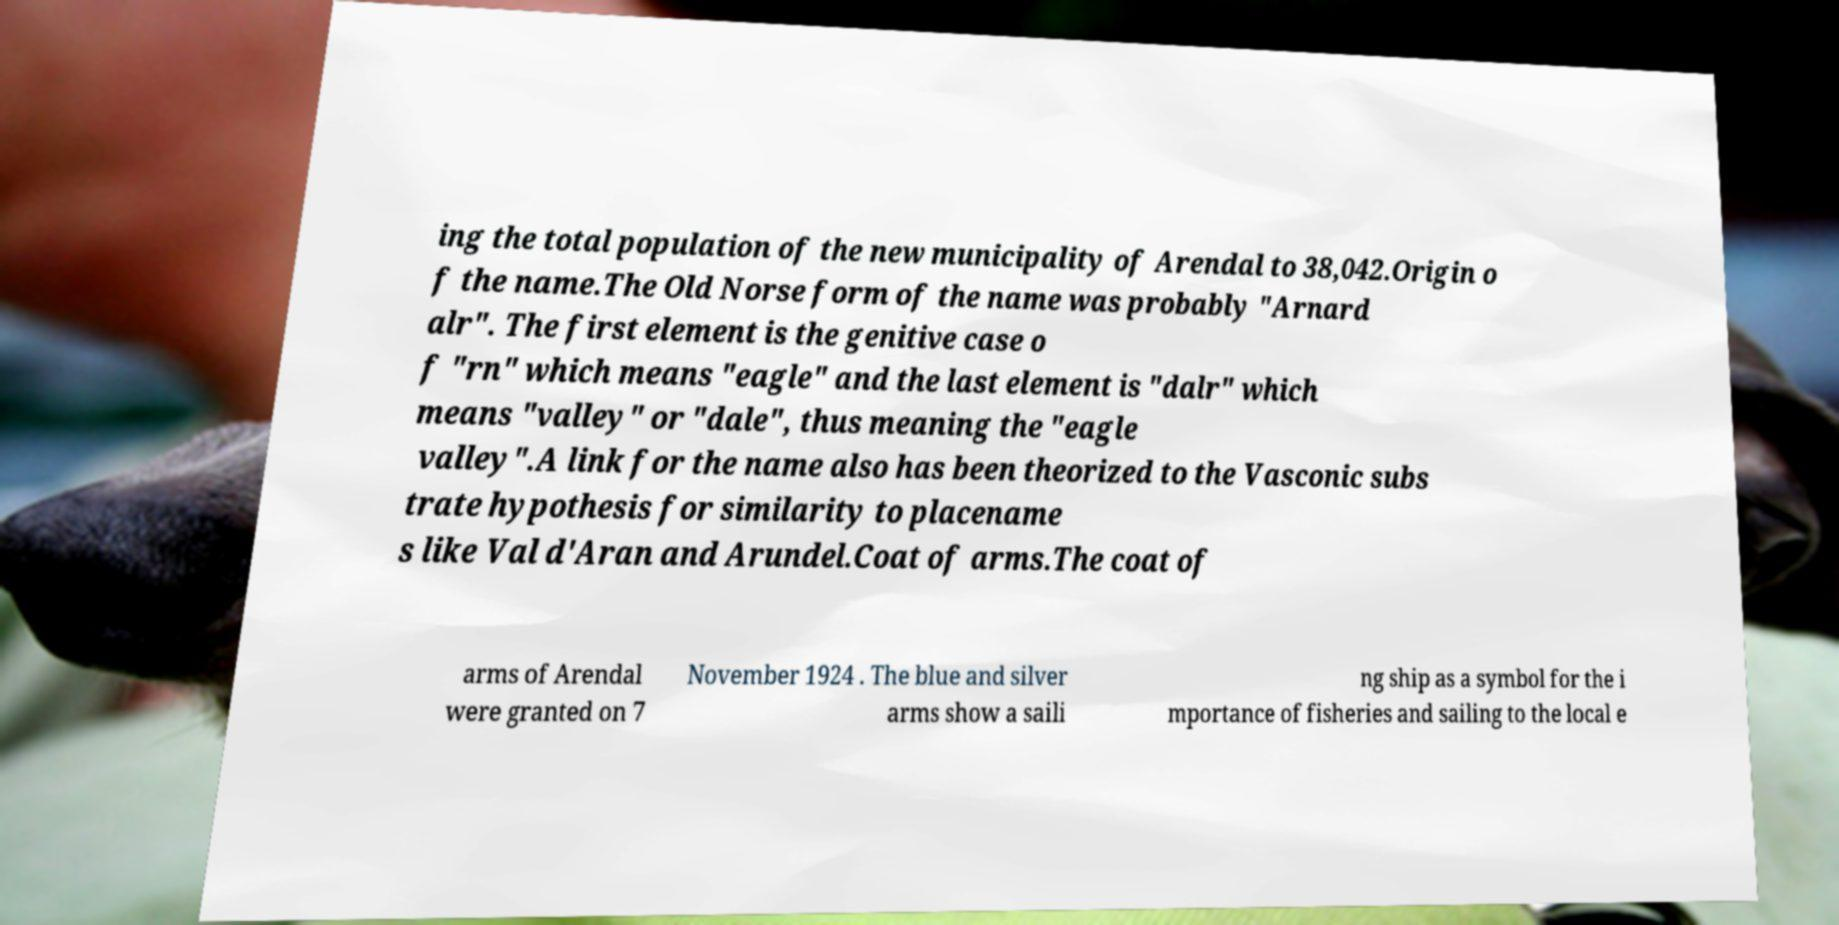Please read and relay the text visible in this image. What does it say? ing the total population of the new municipality of Arendal to 38,042.Origin o f the name.The Old Norse form of the name was probably "Arnard alr". The first element is the genitive case o f "rn" which means "eagle" and the last element is "dalr" which means "valley" or "dale", thus meaning the "eagle valley".A link for the name also has been theorized to the Vasconic subs trate hypothesis for similarity to placename s like Val d'Aran and Arundel.Coat of arms.The coat of arms of Arendal were granted on 7 November 1924 . The blue and silver arms show a saili ng ship as a symbol for the i mportance of fisheries and sailing to the local e 